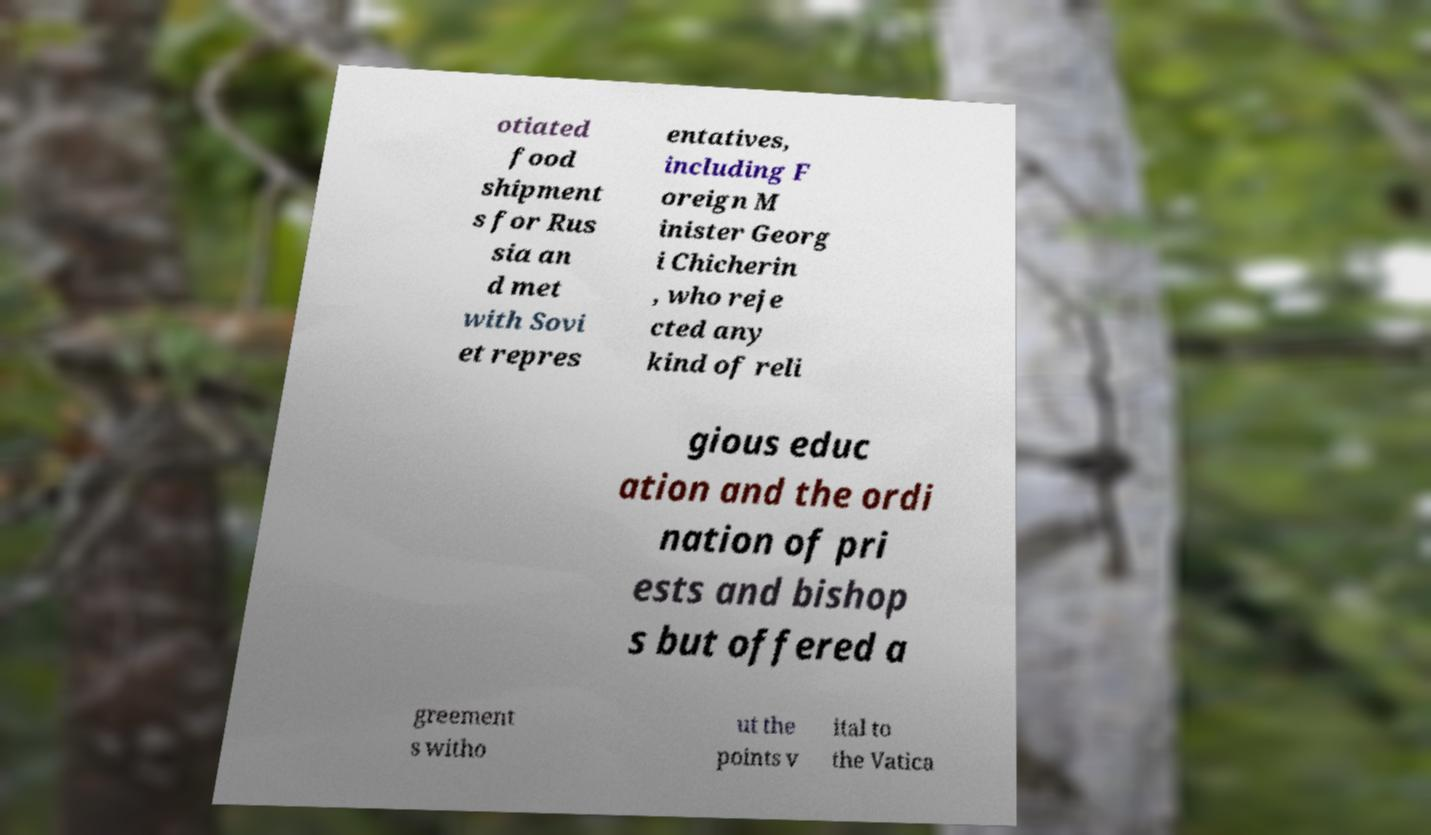Please read and relay the text visible in this image. What does it say? otiated food shipment s for Rus sia an d met with Sovi et repres entatives, including F oreign M inister Georg i Chicherin , who reje cted any kind of reli gious educ ation and the ordi nation of pri ests and bishop s but offered a greement s witho ut the points v ital to the Vatica 